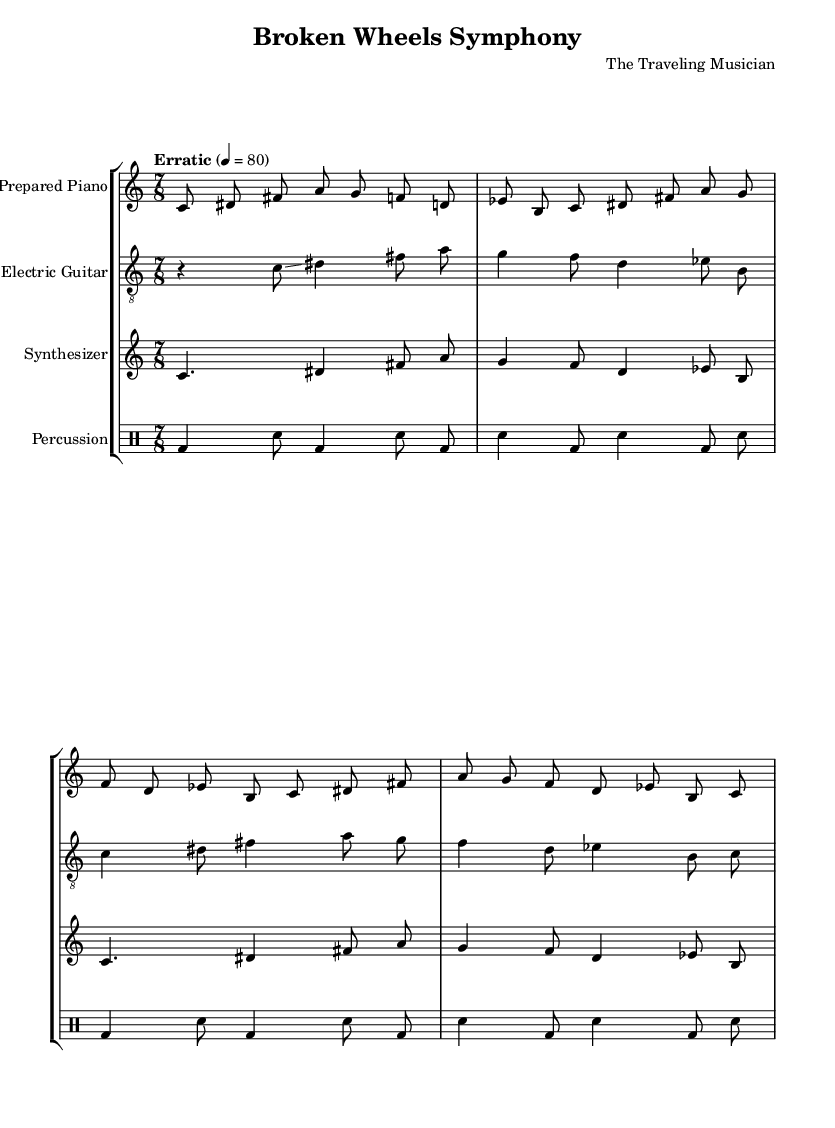What is the title of this composition? The title is indicated in the header section of the sheet music as "Broken Wheels Symphony."
Answer: Broken Wheels Symphony What instruments are used in this piece? The instruments are listed as prepared piano, electric guitar, synthesizer, and percussion in the staff headers.
Answer: Prepared Piano, Electric Guitar, Synthesizer, Percussion What is the time signature of the piece? The time signature is specified at the beginning of the score as 7/8, which can be seen in the global context.
Answer: 7/8 What is the tempo marking of the music? The tempo is marked as "Erratic," with a metronome indication of 4 equals 80, provided in the global section.
Answer: Erratic How many measures are in the prepared piano part? To determine this, count the number of vertical bar lines in the prepared piano section. There are four measures in the prepared piano part.
Answer: 4 Describe the rhythmic pattern of the percussion section. The percussion section alternates between bass drum and snare hits, with a consistent pattern of four measures observed. The rhythm is irregular and mimics mechanical sounds, fitting the experimental theme.
Answer: Alternating bass drum and snare What is the significance of using a glissando in the electric guitar part? The presence of a glissando in the electric guitar's rhythm creates a fluid, sliding effect, contributing to the experimental soundscape and mimicking the unpredictable noises of a malfunctioning tour bus.
Answer: Fluid sound 